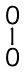<formula> <loc_0><loc_0><loc_500><loc_500>\begin{smallmatrix} 0 \\ 1 \\ 0 \end{smallmatrix}</formula> 